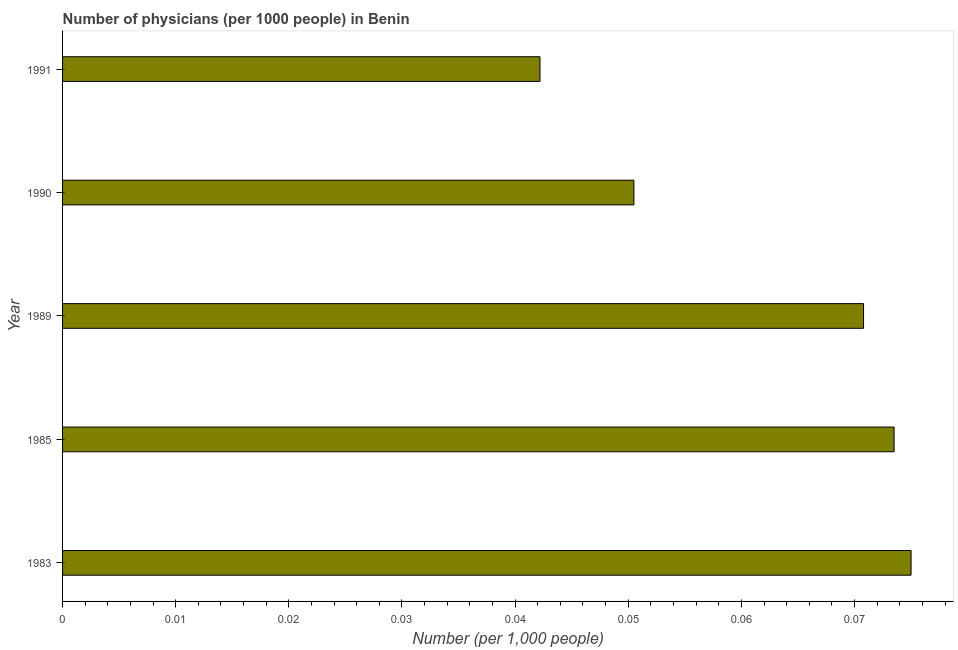What is the title of the graph?
Offer a terse response. Number of physicians (per 1000 people) in Benin. What is the label or title of the X-axis?
Your answer should be very brief. Number (per 1,0 people). What is the label or title of the Y-axis?
Offer a very short reply. Year. What is the number of physicians in 1983?
Keep it short and to the point. 0.08. Across all years, what is the maximum number of physicians?
Offer a terse response. 0.08. Across all years, what is the minimum number of physicians?
Provide a succinct answer. 0.04. In which year was the number of physicians maximum?
Provide a succinct answer. 1983. In which year was the number of physicians minimum?
Offer a very short reply. 1991. What is the sum of the number of physicians?
Make the answer very short. 0.31. What is the difference between the number of physicians in 1990 and 1991?
Ensure brevity in your answer.  0.01. What is the average number of physicians per year?
Your answer should be very brief. 0.06. What is the median number of physicians?
Give a very brief answer. 0.07. In how many years, is the number of physicians greater than 0.014 ?
Offer a very short reply. 5. What is the ratio of the number of physicians in 1990 to that in 1991?
Offer a very short reply. 1.2. Is the number of physicians in 1985 less than that in 1991?
Provide a succinct answer. No. What is the difference between the highest and the second highest number of physicians?
Your answer should be very brief. 0. How many years are there in the graph?
Provide a succinct answer. 5. What is the Number (per 1,000 people) of 1983?
Make the answer very short. 0.08. What is the Number (per 1,000 people) in 1985?
Your response must be concise. 0.07. What is the Number (per 1,000 people) of 1989?
Make the answer very short. 0.07. What is the Number (per 1,000 people) of 1990?
Make the answer very short. 0.05. What is the Number (per 1,000 people) in 1991?
Make the answer very short. 0.04. What is the difference between the Number (per 1,000 people) in 1983 and 1985?
Make the answer very short. 0. What is the difference between the Number (per 1,000 people) in 1983 and 1989?
Keep it short and to the point. 0. What is the difference between the Number (per 1,000 people) in 1983 and 1990?
Provide a succinct answer. 0.02. What is the difference between the Number (per 1,000 people) in 1983 and 1991?
Your response must be concise. 0.03. What is the difference between the Number (per 1,000 people) in 1985 and 1989?
Make the answer very short. 0. What is the difference between the Number (per 1,000 people) in 1985 and 1990?
Your response must be concise. 0.02. What is the difference between the Number (per 1,000 people) in 1985 and 1991?
Provide a succinct answer. 0.03. What is the difference between the Number (per 1,000 people) in 1989 and 1990?
Your response must be concise. 0.02. What is the difference between the Number (per 1,000 people) in 1989 and 1991?
Provide a succinct answer. 0.03. What is the difference between the Number (per 1,000 people) in 1990 and 1991?
Offer a very short reply. 0.01. What is the ratio of the Number (per 1,000 people) in 1983 to that in 1989?
Make the answer very short. 1.06. What is the ratio of the Number (per 1,000 people) in 1983 to that in 1990?
Ensure brevity in your answer.  1.49. What is the ratio of the Number (per 1,000 people) in 1983 to that in 1991?
Your answer should be compact. 1.78. What is the ratio of the Number (per 1,000 people) in 1985 to that in 1989?
Give a very brief answer. 1.04. What is the ratio of the Number (per 1,000 people) in 1985 to that in 1990?
Offer a terse response. 1.46. What is the ratio of the Number (per 1,000 people) in 1985 to that in 1991?
Offer a terse response. 1.74. What is the ratio of the Number (per 1,000 people) in 1989 to that in 1990?
Offer a very short reply. 1.4. What is the ratio of the Number (per 1,000 people) in 1989 to that in 1991?
Ensure brevity in your answer.  1.68. What is the ratio of the Number (per 1,000 people) in 1990 to that in 1991?
Ensure brevity in your answer.  1.2. 